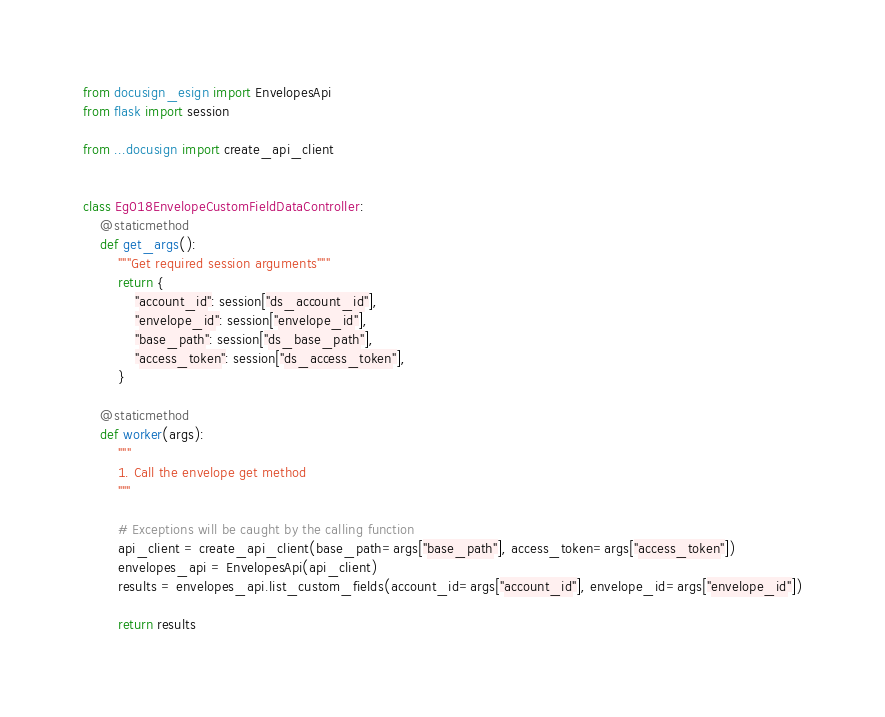<code> <loc_0><loc_0><loc_500><loc_500><_Python_>from docusign_esign import EnvelopesApi
from flask import session

from ...docusign import create_api_client


class Eg018EnvelopeCustomFieldDataController:
    @staticmethod
    def get_args():
        """Get required session arguments"""
        return {
            "account_id": session["ds_account_id"],
            "envelope_id": session["envelope_id"],
            "base_path": session["ds_base_path"],
            "access_token": session["ds_access_token"],
        }

    @staticmethod
    def worker(args):
        """
        1. Call the envelope get method
        """

        # Exceptions will be caught by the calling function
        api_client = create_api_client(base_path=args["base_path"], access_token=args["access_token"])
        envelopes_api = EnvelopesApi(api_client)
        results = envelopes_api.list_custom_fields(account_id=args["account_id"], envelope_id=args["envelope_id"])

        return results
</code> 